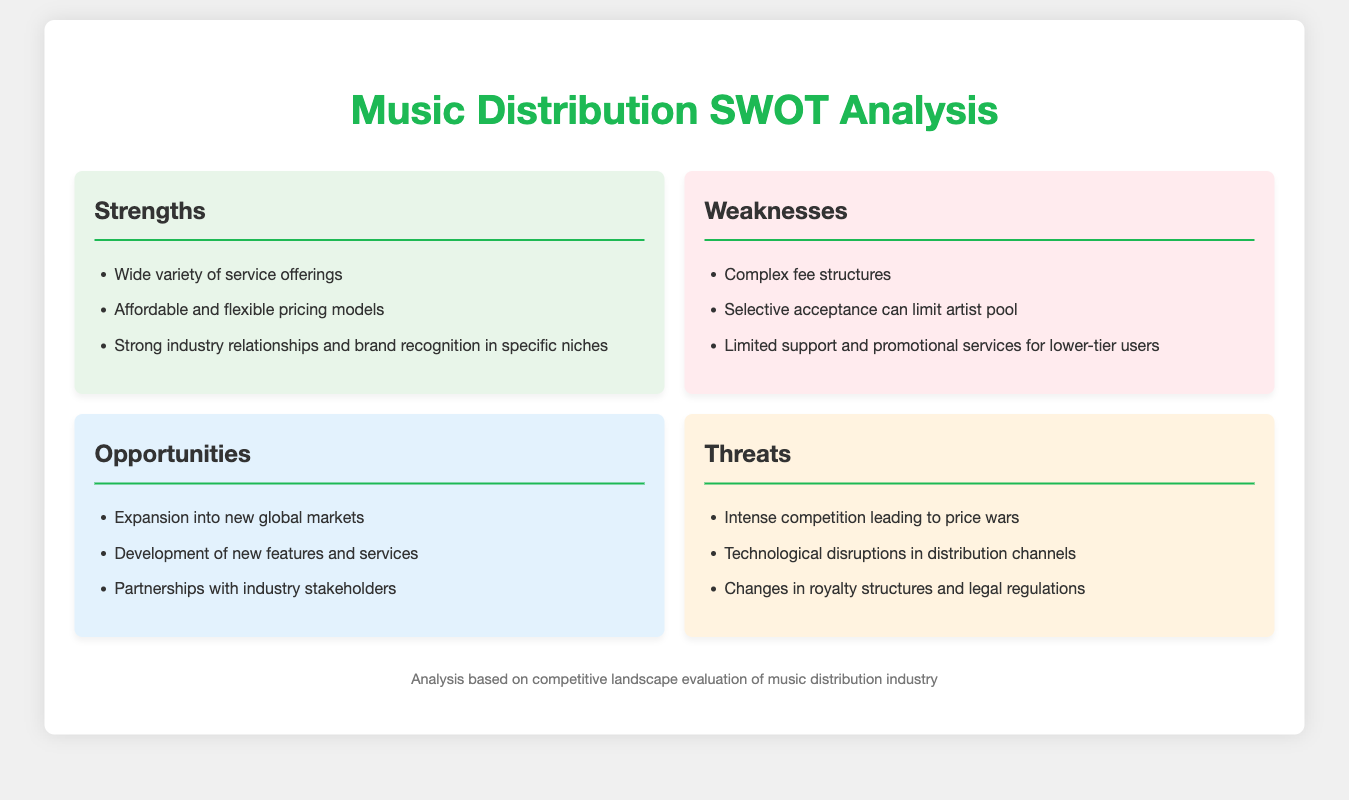what are the strengths listed in the SWOT analysis? The strengths listed are wide variety of service offerings, affordable and flexible pricing models, and strong industry relationships and brand recognition in specific niches.
Answer: wide variety of service offerings, affordable and flexible pricing models, strong industry relationships and brand recognition in specific niches what is one of the weaknesses mentioned? One of the weaknesses mentioned is complex fee structures.
Answer: complex fee structures how many opportunities are identified in the document? The document identifies three opportunities: expansion into new global markets, development of new features and services, and partnerships with industry stakeholders.
Answer: three what do intense competition lead to according to the threats section? According to the threats section, intense competition leads to price wars.
Answer: price wars what color is used for the threats section? The threats section background color is a light shade, specifically noted to be used for highlighting threats in the SWOT grid.
Answer: light shade (specifically noted as #fff3e0) 